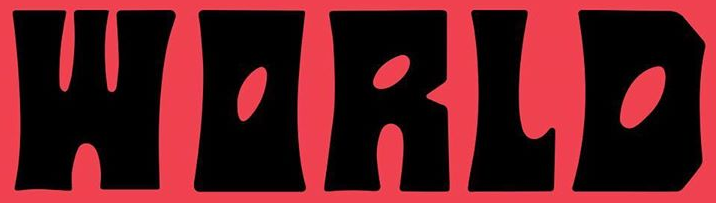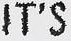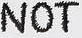Identify the words shown in these images in order, separated by a semicolon. WORLD; IT'S; NOT 